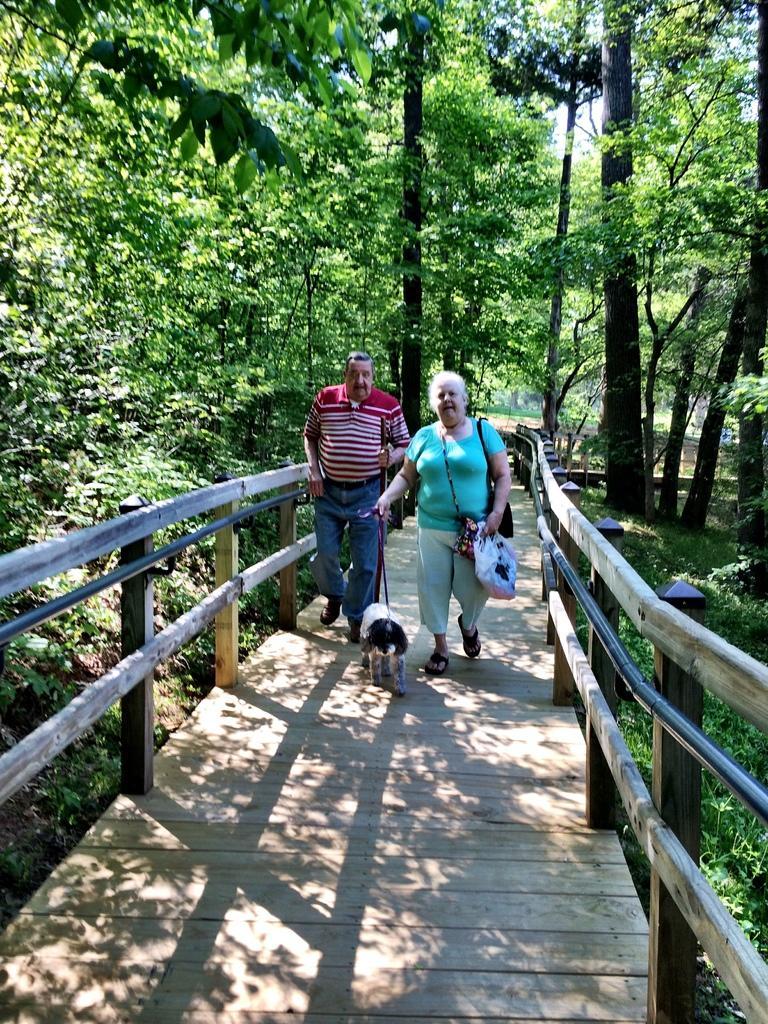Describe this image in one or two sentences. These two persons are walking on a bridge, as there is a movement in there legs. In between of them there is a dog. This bridge is surround with number of trees. This woman wore bag and holding a plastic bag. 